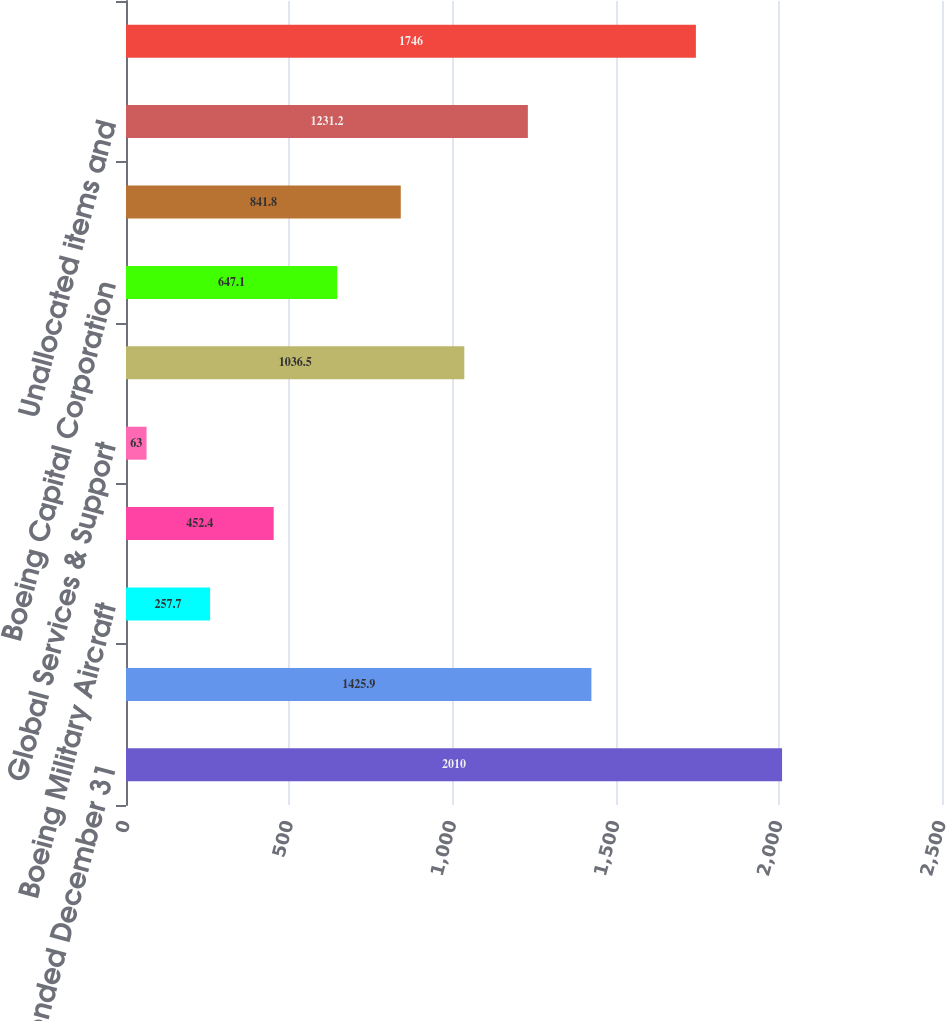Convert chart to OTSL. <chart><loc_0><loc_0><loc_500><loc_500><bar_chart><fcel>Years ended December 31<fcel>Commercial Airplanes<fcel>Boeing Military Aircraft<fcel>Network & Space Systems<fcel>Global Services & Support<fcel>Total Defense Space & Security<fcel>Boeing Capital Corporation<fcel>Other segment<fcel>Unallocated items and<fcel>Total<nl><fcel>2010<fcel>1425.9<fcel>257.7<fcel>452.4<fcel>63<fcel>1036.5<fcel>647.1<fcel>841.8<fcel>1231.2<fcel>1746<nl></chart> 